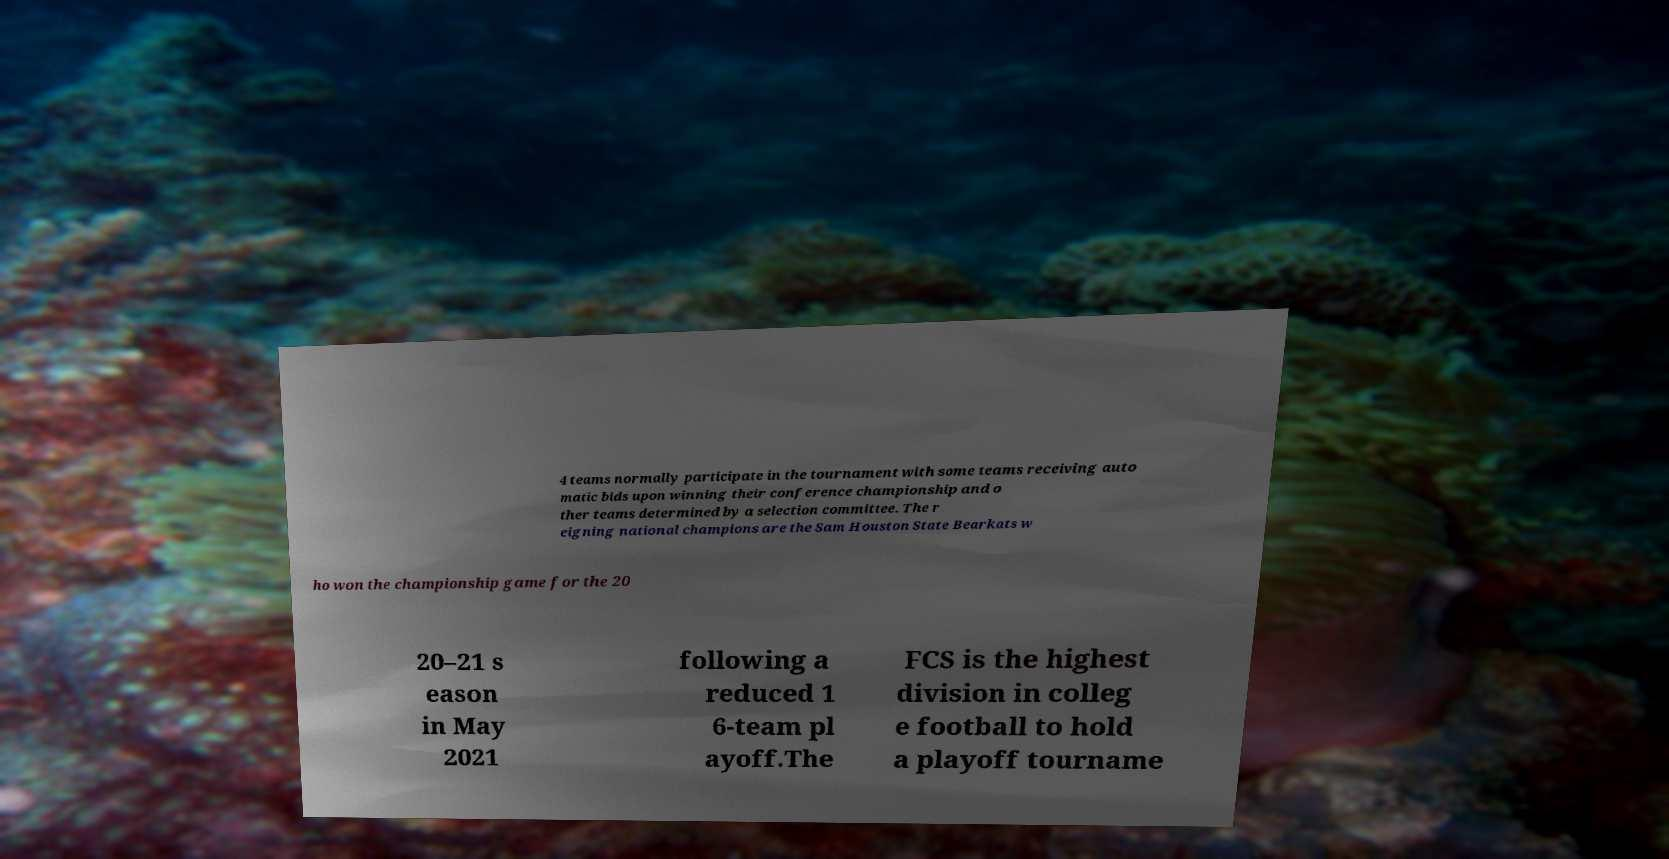Please identify and transcribe the text found in this image. 4 teams normally participate in the tournament with some teams receiving auto matic bids upon winning their conference championship and o ther teams determined by a selection committee. The r eigning national champions are the Sam Houston State Bearkats w ho won the championship game for the 20 20–21 s eason in May 2021 following a reduced 1 6-team pl ayoff.The FCS is the highest division in colleg e football to hold a playoff tourname 